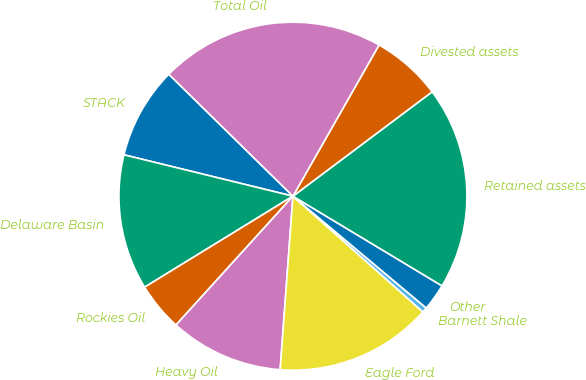Convert chart. <chart><loc_0><loc_0><loc_500><loc_500><pie_chart><fcel>STACK<fcel>Delaware Basin<fcel>Rockies Oil<fcel>Heavy Oil<fcel>Eagle Ford<fcel>Barnett Shale<fcel>Other<fcel>Retained assets<fcel>Divested assets<fcel>Total Oil<nl><fcel>8.54%<fcel>12.58%<fcel>4.51%<fcel>10.56%<fcel>14.59%<fcel>0.47%<fcel>2.49%<fcel>18.86%<fcel>6.52%<fcel>20.88%<nl></chart> 